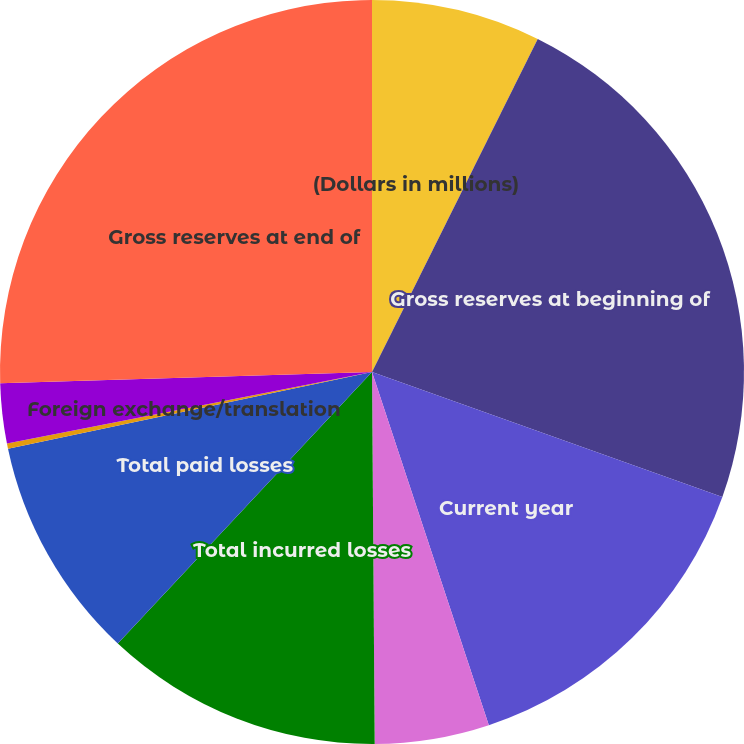Convert chart to OTSL. <chart><loc_0><loc_0><loc_500><loc_500><pie_chart><fcel>(Dollars in millions)<fcel>Gross reserves at beginning of<fcel>Current year<fcel>Prior years<fcel>Total incurred losses<fcel>Total paid losses<fcel>Foreign exchange/translation<fcel>Change in reinsurance<fcel>Gross reserves at end of<nl><fcel>7.35%<fcel>23.11%<fcel>14.46%<fcel>4.97%<fcel>12.09%<fcel>9.72%<fcel>0.23%<fcel>2.6%<fcel>25.48%<nl></chart> 